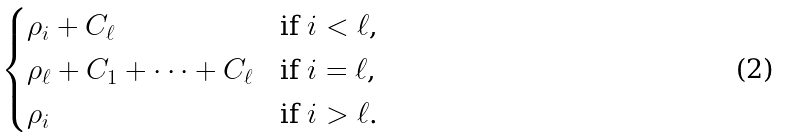<formula> <loc_0><loc_0><loc_500><loc_500>\begin{cases} \rho _ { i } + C _ { \ell } & \text {if $i<\ell$,} \\ \rho _ { \ell } + C _ { 1 } + \cdots + C _ { \ell } & \text {if $i=\ell$,} \\ \rho _ { i } & \text {if $i>\ell$.} \end{cases}</formula> 